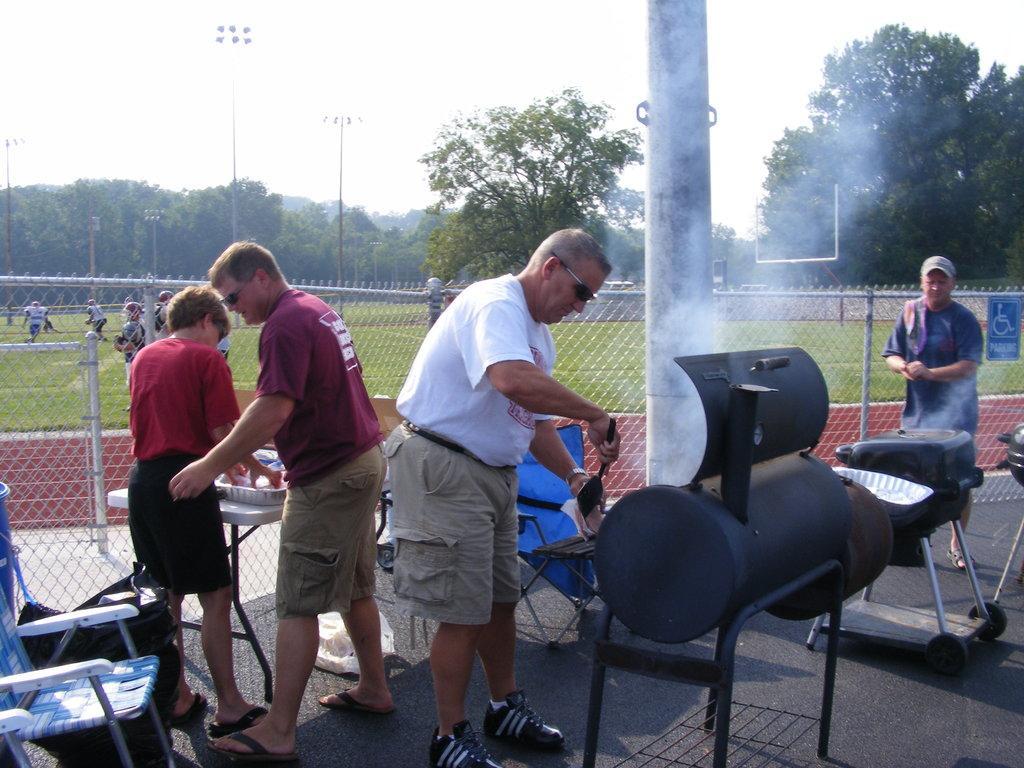Please provide a concise description of this image. In this picture we can see few people, chairs, table on the ground, here we can see few objects and in the background we can see a fence, few people, trees, poles and the sky. 